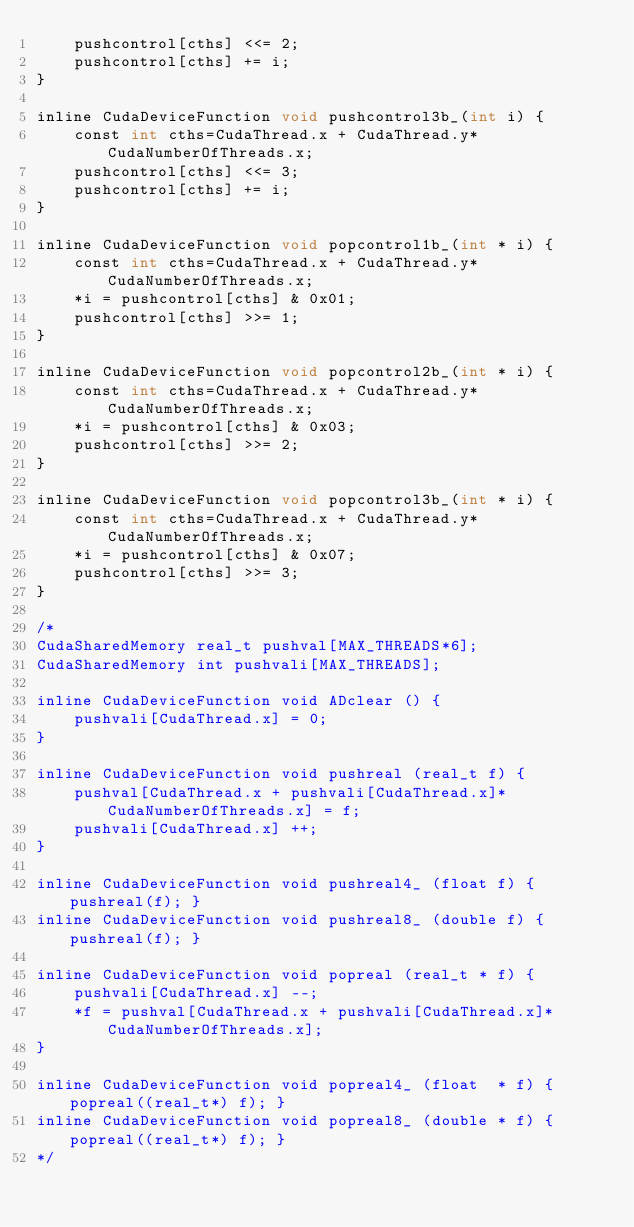Convert code to text. <code><loc_0><loc_0><loc_500><loc_500><_Cuda_>	pushcontrol[cths] <<= 2;
	pushcontrol[cths] += i;
}

inline CudaDeviceFunction void pushcontrol3b_(int i) {
	const int cths=CudaThread.x + CudaThread.y*CudaNumberOfThreads.x;
	pushcontrol[cths] <<= 3;
	pushcontrol[cths] += i;
}

inline CudaDeviceFunction void popcontrol1b_(int * i) {
	const int cths=CudaThread.x + CudaThread.y*CudaNumberOfThreads.x;
	*i = pushcontrol[cths] & 0x01;
	pushcontrol[cths] >>= 1;
}

inline CudaDeviceFunction void popcontrol2b_(int * i) {
	const int cths=CudaThread.x + CudaThread.y*CudaNumberOfThreads.x;
	*i = pushcontrol[cths] & 0x03;
	pushcontrol[cths] >>= 2;
}

inline CudaDeviceFunction void popcontrol3b_(int * i) {
	const int cths=CudaThread.x + CudaThread.y*CudaNumberOfThreads.x;
	*i = pushcontrol[cths] & 0x07;
	pushcontrol[cths] >>= 3;
}

/*	
CudaSharedMemory real_t pushval[MAX_THREADS*6];
CudaSharedMemory int pushvali[MAX_THREADS];

inline CudaDeviceFunction void ADclear () {
	pushvali[CudaThread.x] = 0;
}

inline CudaDeviceFunction void pushreal (real_t f) {
	pushval[CudaThread.x + pushvali[CudaThread.x]*CudaNumberOfThreads.x] = f;
	pushvali[CudaThread.x] ++;
}

inline CudaDeviceFunction void pushreal4_ (float f) { pushreal(f); }
inline CudaDeviceFunction void pushreal8_ (double f) { pushreal(f); }

inline CudaDeviceFunction void popreal (real_t * f) {
	pushvali[CudaThread.x] --;
	*f = pushval[CudaThread.x + pushvali[CudaThread.x]*CudaNumberOfThreads.x];
}

inline CudaDeviceFunction void popreal4_ (float  * f) { popreal((real_t*) f); }
inline CudaDeviceFunction void popreal8_ (double * f) { popreal((real_t*) f); }
*/
</code> 